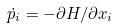Convert formula to latex. <formula><loc_0><loc_0><loc_500><loc_500>\dot { p } _ { i } = - \partial H / \partial x _ { i }</formula> 